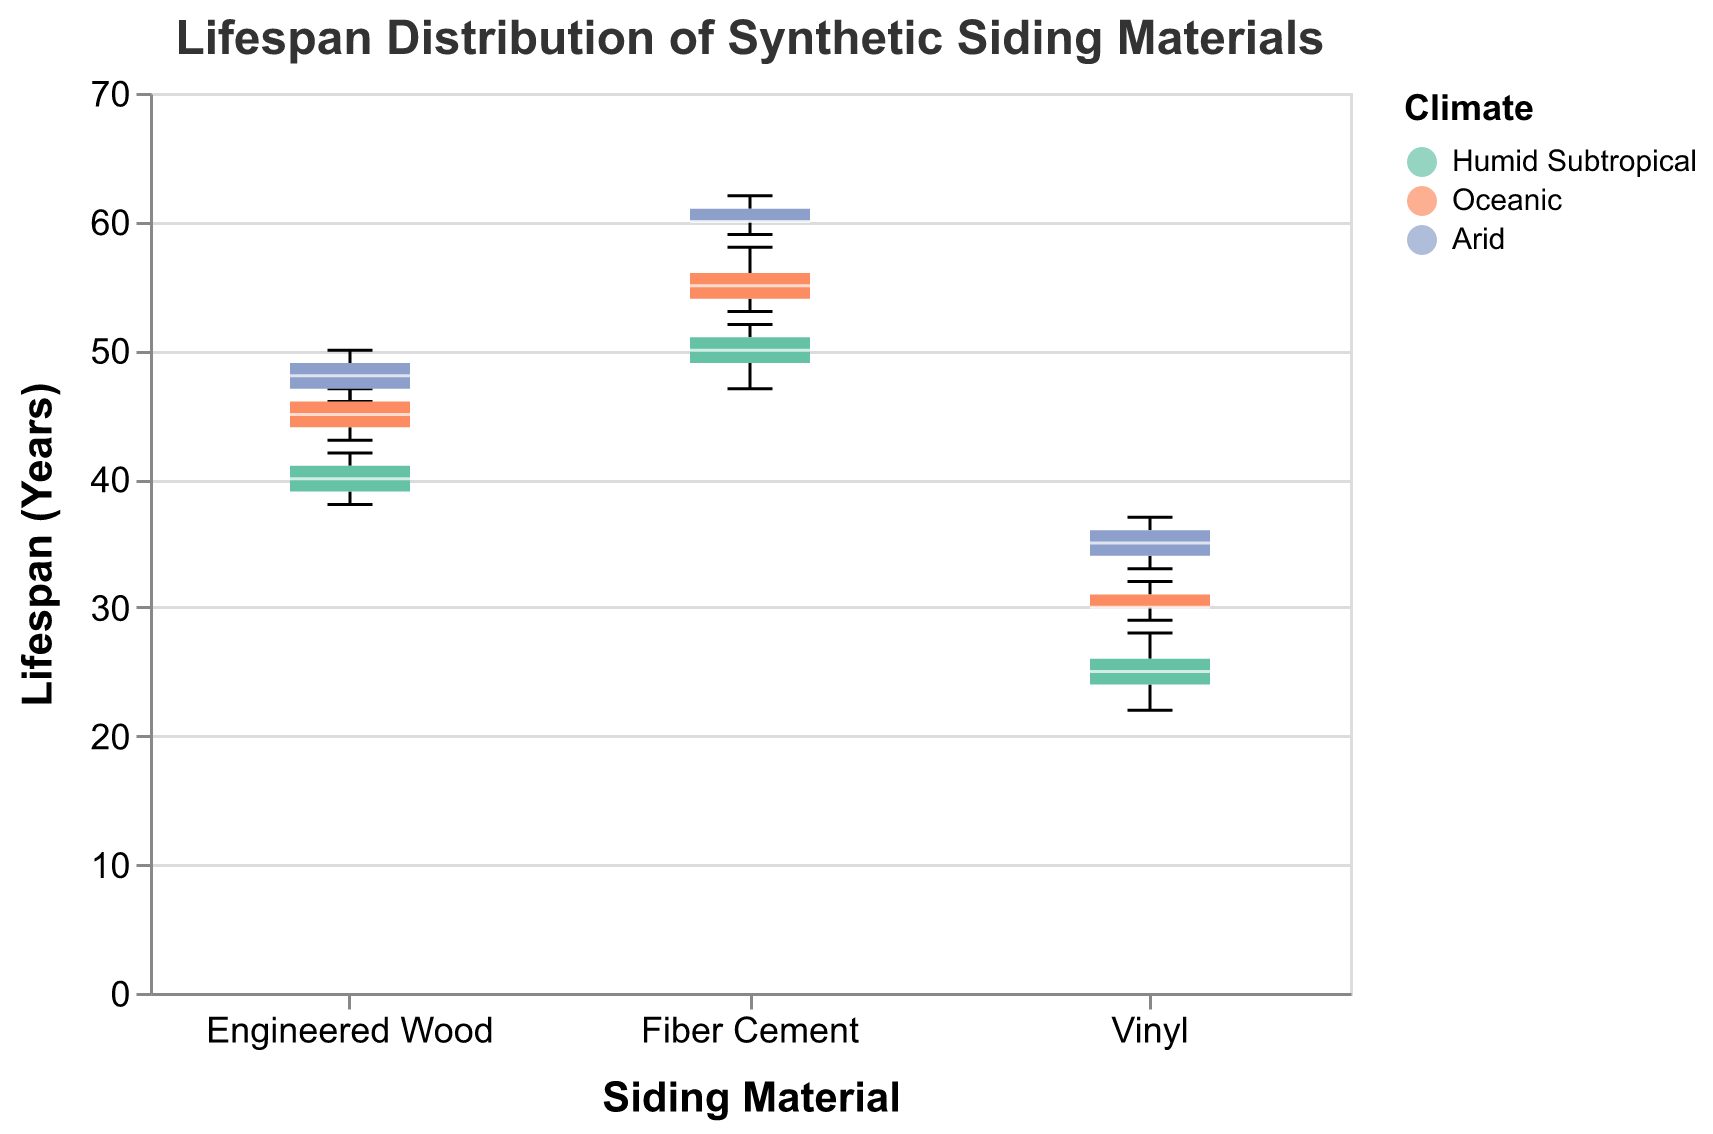What is the title of the figure? The title of the figure is always shown clearly at the top. In this case, it is "Lifespan Distribution of Synthetic Siding Materials".
Answer: Lifespan Distribution of Synthetic Siding Materials What are the different climates represented in the box plot by different colors? The legend on the side of the plot labels the respective colors for each climate: "#66c2a5" for Humid Subtropical, "#fc8d62" for Oceanic, and "#8da0cb" for Arid.
Answer: Humid Subtropical, Oceanic, Arid Which siding material shows the highest median lifespan in an Arid climate? The median lifespan is represented by the white line in the middle of each box. By comparing the boxes, Fiber Cement in the Arid climate has the highest median among all materials in Arid climate.
Answer: Fiber Cement What is the median lifespan of Vinyl in an Oceanic climate? To find the median, look at the white line in the box plot for Vinyl under the Oceanic climate color. This line appears to be at 30 years.
Answer: 30 years Which siding material has the most variation in lifespan in an Oceanic climate? Variation is shown by the height of the box. The taller the box, the greater the variation. Among the materials in an Oceanic climate, Fiber Cement shows the most variation in the box plot.
Answer: Fiber Cement How does the lifespan of Engineered Wood in an Humid Subtropical climate compare to Fiber Cement in the same climate? By comparing the medians for both materials in Humid Subtropical climate, which are the white lines in their respective boxes, Fiber Cement has a higher median lifespan than Engineered Wood.
Answer: Fiber Cement has a higher median lifespan In which climate does Vinyl have the longest lifespan? Look at the upper end of the whiskers for Vinyl in all three climates. Vinyl in Arid climate shows the longest maximum lifespan compared to Humid Subtropical and Oceanic climates.
Answer: Arid What is the lowest observed lifespan for Fiber Cement in any climate? The lowest point of the whiskers represents the minimum observed lifespan. For Fiber Cement, the minimum whisker length occurs in Humid Subtropical climate at 47 years.
Answer: 47 years 